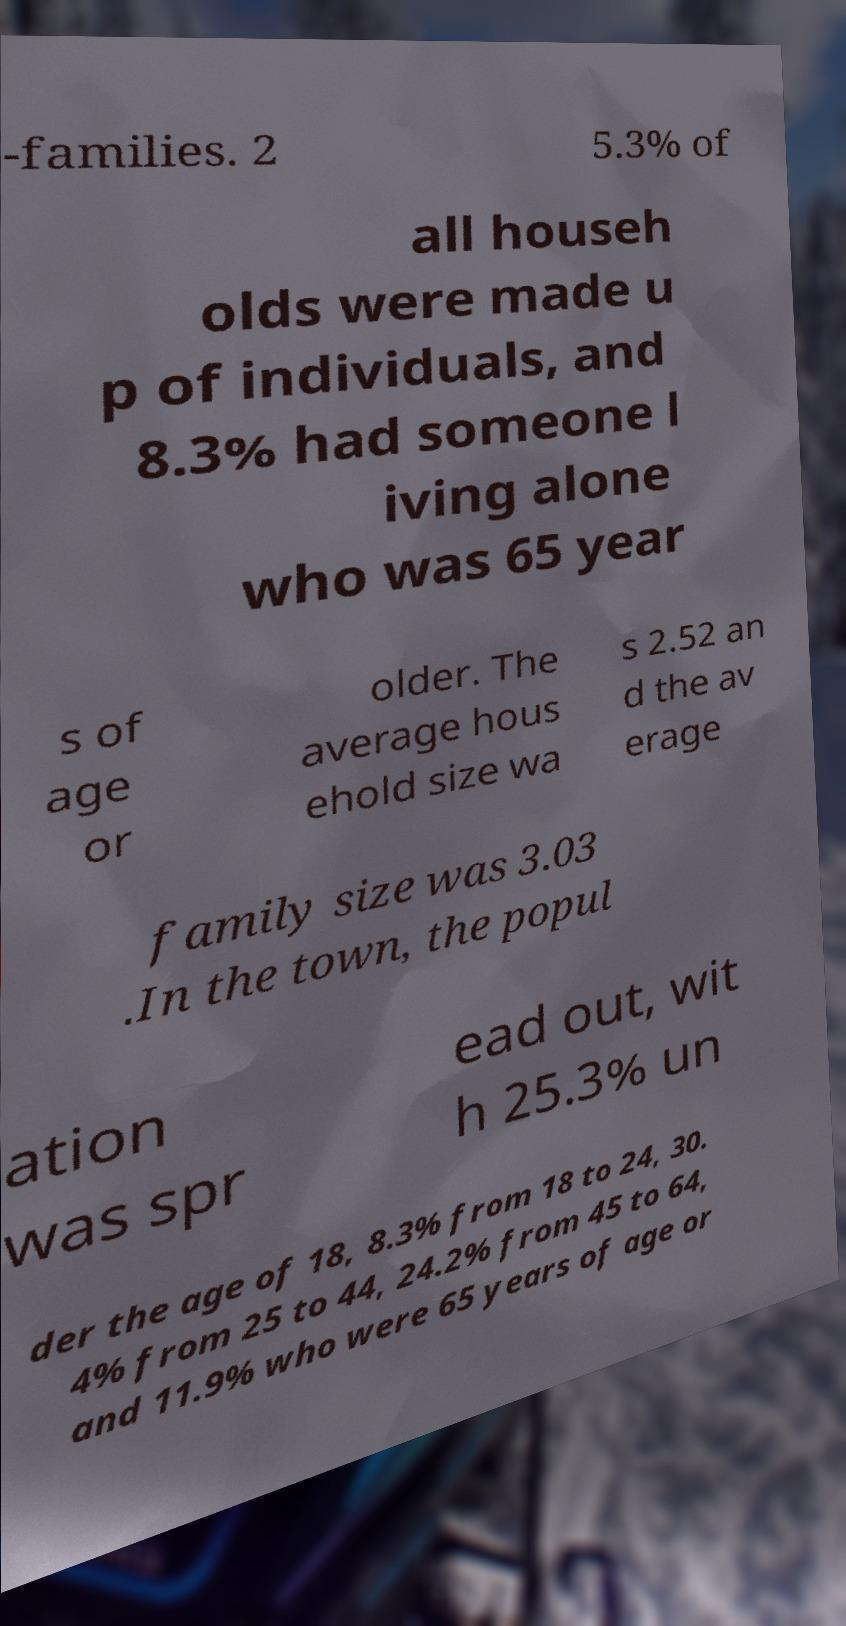Could you extract and type out the text from this image? -families. 2 5.3% of all househ olds were made u p of individuals, and 8.3% had someone l iving alone who was 65 year s of age or older. The average hous ehold size wa s 2.52 an d the av erage family size was 3.03 .In the town, the popul ation was spr ead out, wit h 25.3% un der the age of 18, 8.3% from 18 to 24, 30. 4% from 25 to 44, 24.2% from 45 to 64, and 11.9% who were 65 years of age or 